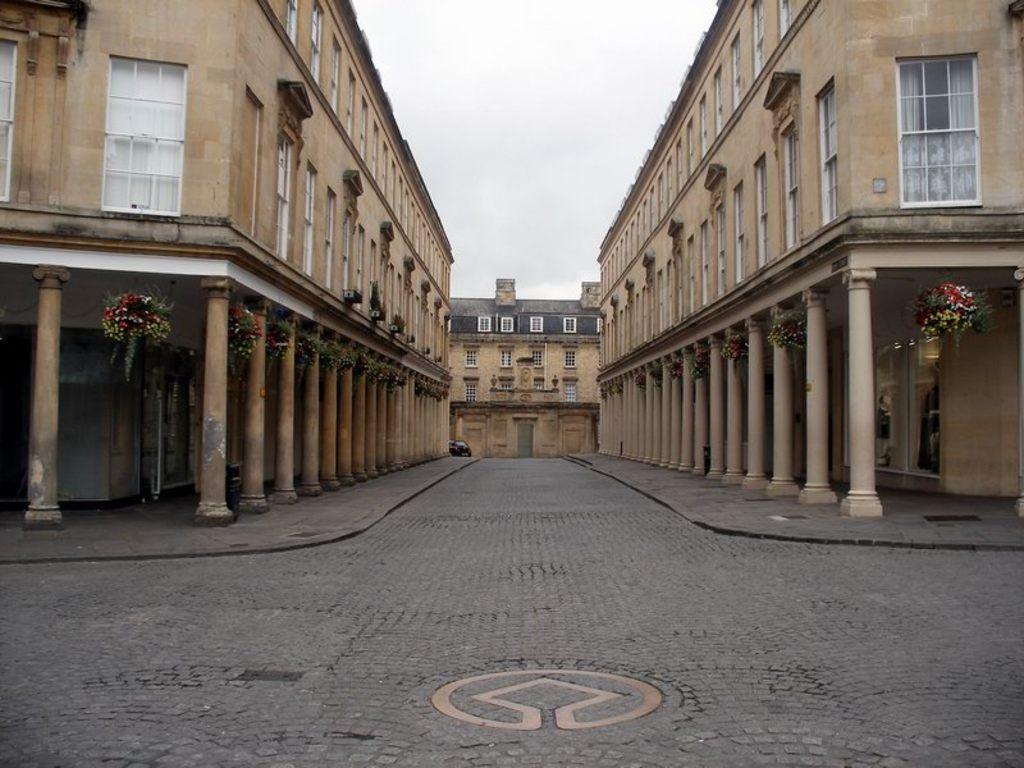Can you describe this image briefly? In the image there is a pavement and around the pavement there are buildings. 